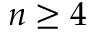<formula> <loc_0><loc_0><loc_500><loc_500>n \geq 4</formula> 